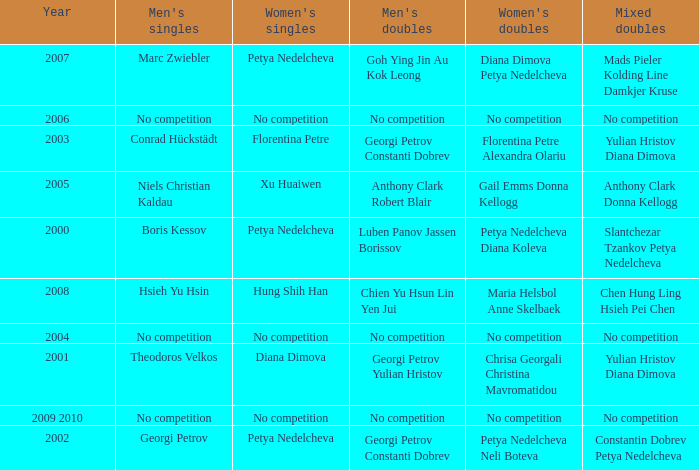In what year was there no competition for women? 2004, 2006, 2009 2010. 